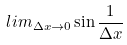<formula> <loc_0><loc_0><loc_500><loc_500>l i m _ { \Delta x \rightarrow 0 } \sin \frac { 1 } { \Delta x }</formula> 